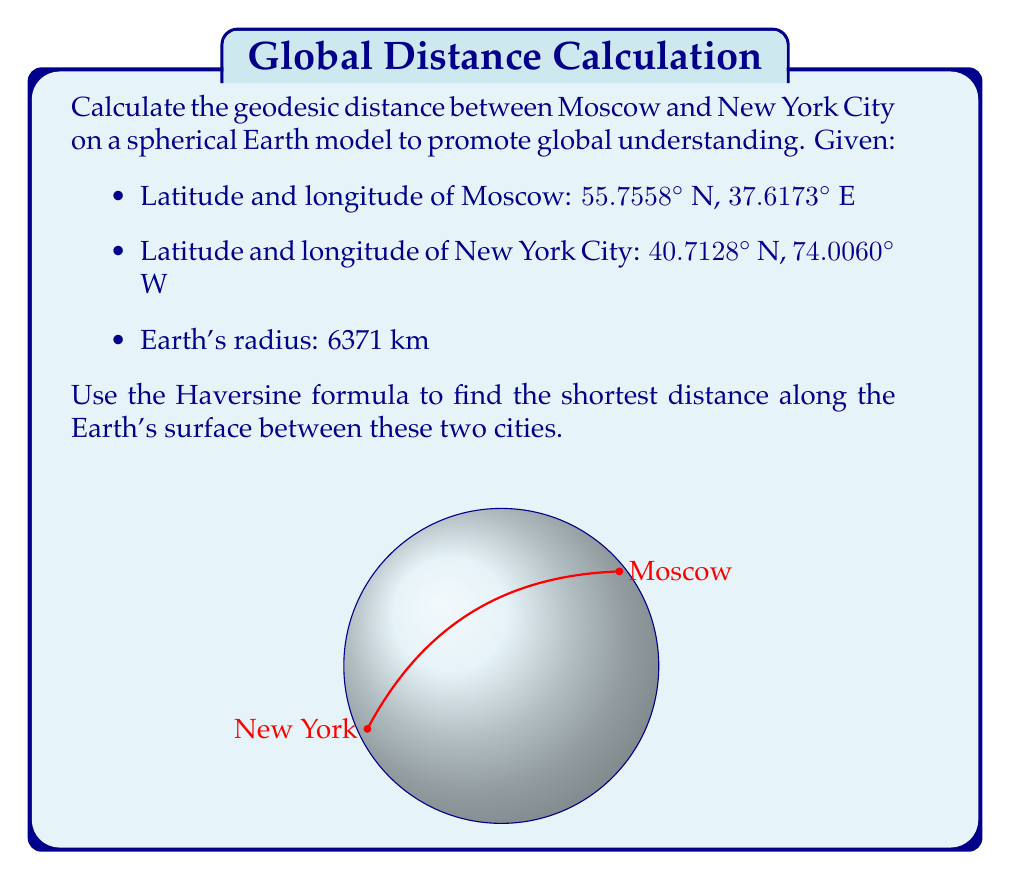Can you answer this question? To calculate the geodesic distance between Moscow and New York City on a spherical Earth model, we'll use the Haversine formula. This formula determines the great-circle distance between two points on a sphere given their longitudes and latitudes.

Step 1: Convert latitudes and longitudes from degrees to radians.
$$\phi_1 = 55.7558° \times \frac{\pi}{180} = 0.9732 \text{ rad}$$
$$\lambda_1 = 37.6173° \times \frac{\pi}{180} = 0.6565 \text{ rad}$$
$$\phi_2 = 40.7128° \times \frac{\pi}{180} = 0.7105 \text{ rad}$$
$$\lambda_2 = -74.0060° \times \frac{\pi}{180} = -1.2915 \text{ rad}$$

Step 2: Calculate the difference in longitude.
$$\Delta\lambda = \lambda_2 - \lambda_1 = -1.2915 - 0.6565 = -1.9480 \text{ rad}$$

Step 3: Apply the Haversine formula:
$$a = \sin^2\left(\frac{\Delta\phi}{2}\right) + \cos\phi_1 \cos\phi_2 \sin^2\left(\frac{\Delta\lambda}{2}\right)$$
$$c = 2 \times \arctan2(\sqrt{a}, \sqrt{1-a})$$
$$d = R \times c$$

Where:
$\Delta\phi = \phi_2 - \phi_1$ (difference in latitude)
$R$ is the Earth's radius (6371 km)

Step 4: Calculate $a$:
$$\Delta\phi = 0.7105 - 0.9732 = -0.2627 \text{ rad}$$
$$a = \sin^2\left(\frac{-0.2627}{2}\right) + \cos(0.9732) \cos(0.7105) \sin^2\left(\frac{-1.9480}{2}\right) = 0.1854$$

Step 5: Calculate $c$:
$$c = 2 \times \arctan2(\sqrt{0.1854}, \sqrt{1-0.1854}) = 0.9007$$

Step 6: Calculate the distance $d$:
$$d = 6371 \times 0.9007 = 5738.5 \text{ km}$$

This calculation demonstrates the shortest distance along the Earth's surface between Moscow and New York City, promoting global understanding by showing how these two distant cities are connected on our spherical planet.
Answer: 5738.5 km 